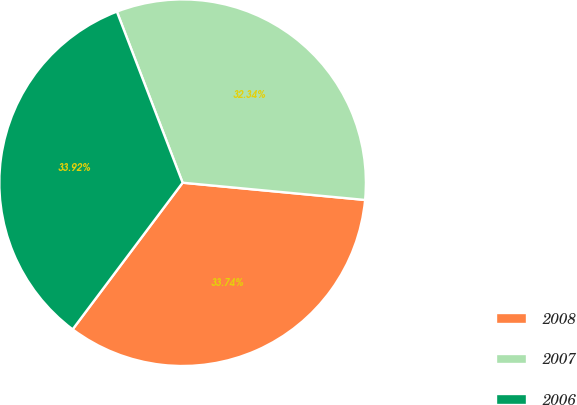<chart> <loc_0><loc_0><loc_500><loc_500><pie_chart><fcel>2008<fcel>2007<fcel>2006<nl><fcel>33.74%<fcel>32.34%<fcel>33.92%<nl></chart> 